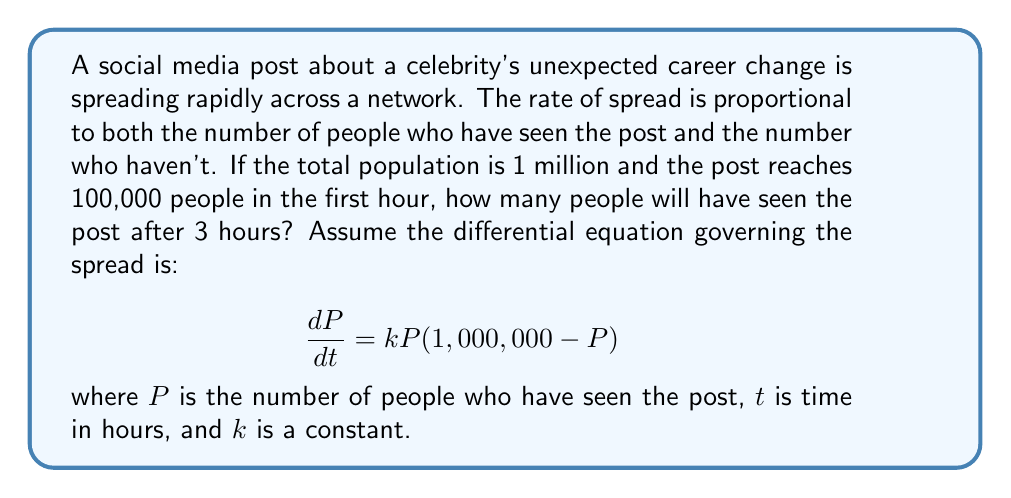Show me your answer to this math problem. Let's solve this step-by-step:

1) First, we need to find the value of $k$ using the initial condition. We know that after 1 hour, $P = 100,000$. Let's substitute this into the equation:

   $$100,000 = 1,000,000 \cdot (1 - e^{-1,000,000k})$$

2) Solving this numerically, we get $k \approx 1.15 \times 10^{-6}$.

3) Now that we have $k$, we can use the general solution for logistic growth:

   $$P(t) = \frac{1,000,000}{1 + (\frac{1,000,000}{P_0} - 1)e^{-1,000,000kt}}$$

   where $P_0$ is the initial number of people who have seen the post. In this case, $P_0 = 100,000$.

4) Substituting our values:

   $$P(t) = \frac{1,000,000}{1 + 9e^{-1.15t}}$$

5) We want to know $P(3)$, so let's substitute $t = 3$:

   $$P(3) = \frac{1,000,000}{1 + 9e^{-3.45}} \approx 690,482$$

6) Rounding to the nearest person, we get 690,482 people.
Answer: 690,482 people 